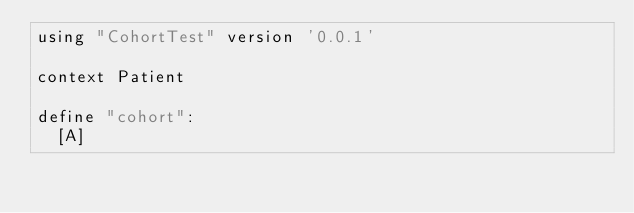<code> <loc_0><loc_0><loc_500><loc_500><_SQL_>using "CohortTest" version '0.0.1'

context Patient
  
define "cohort":
  [A]
</code> 